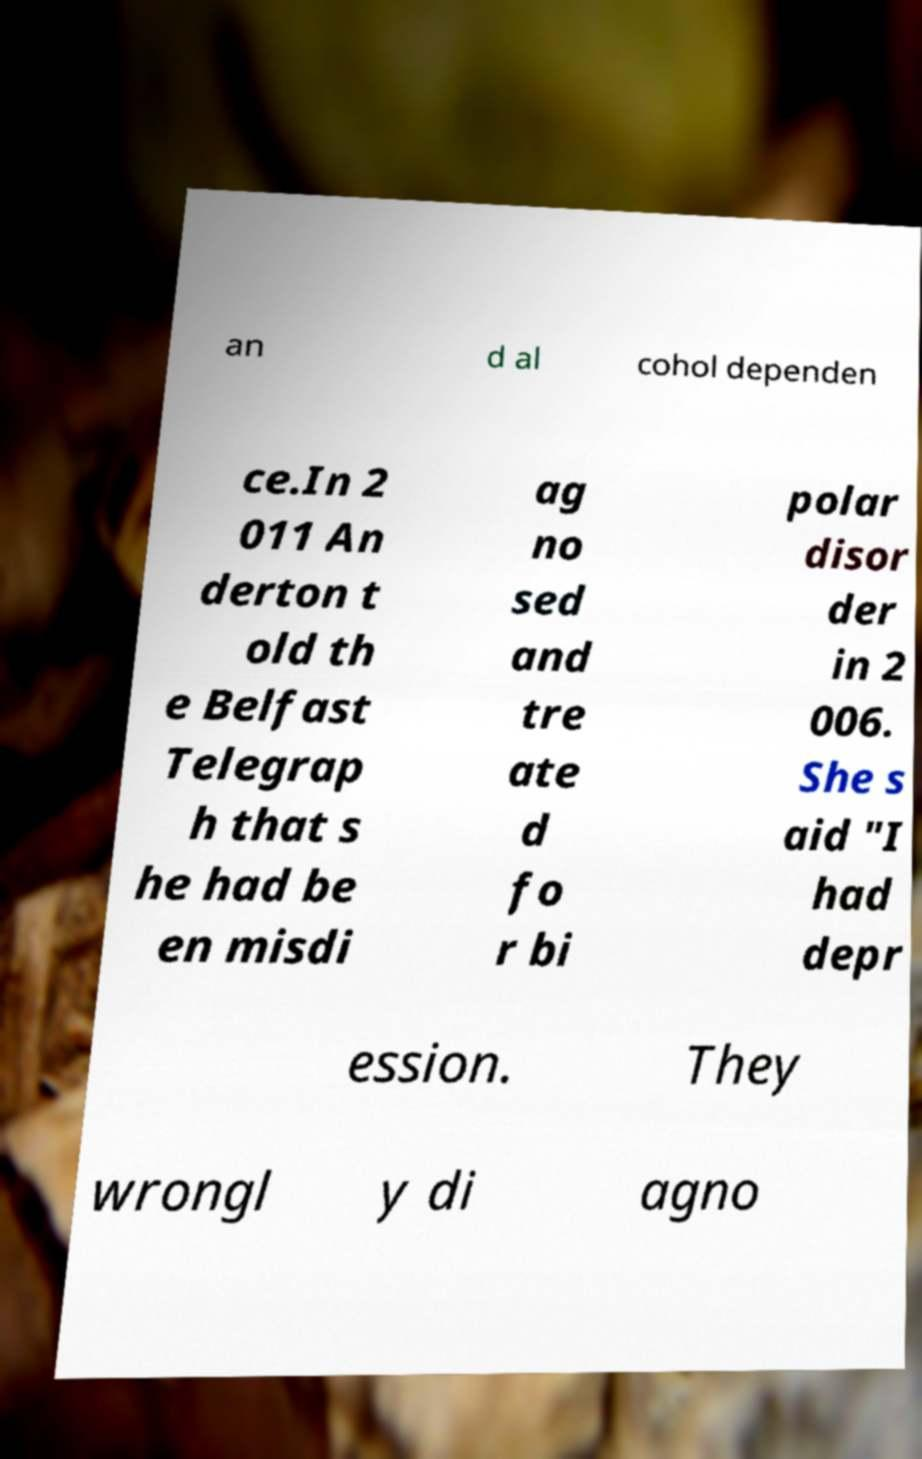For documentation purposes, I need the text within this image transcribed. Could you provide that? an d al cohol dependen ce.In 2 011 An derton t old th e Belfast Telegrap h that s he had be en misdi ag no sed and tre ate d fo r bi polar disor der in 2 006. She s aid "I had depr ession. They wrongl y di agno 